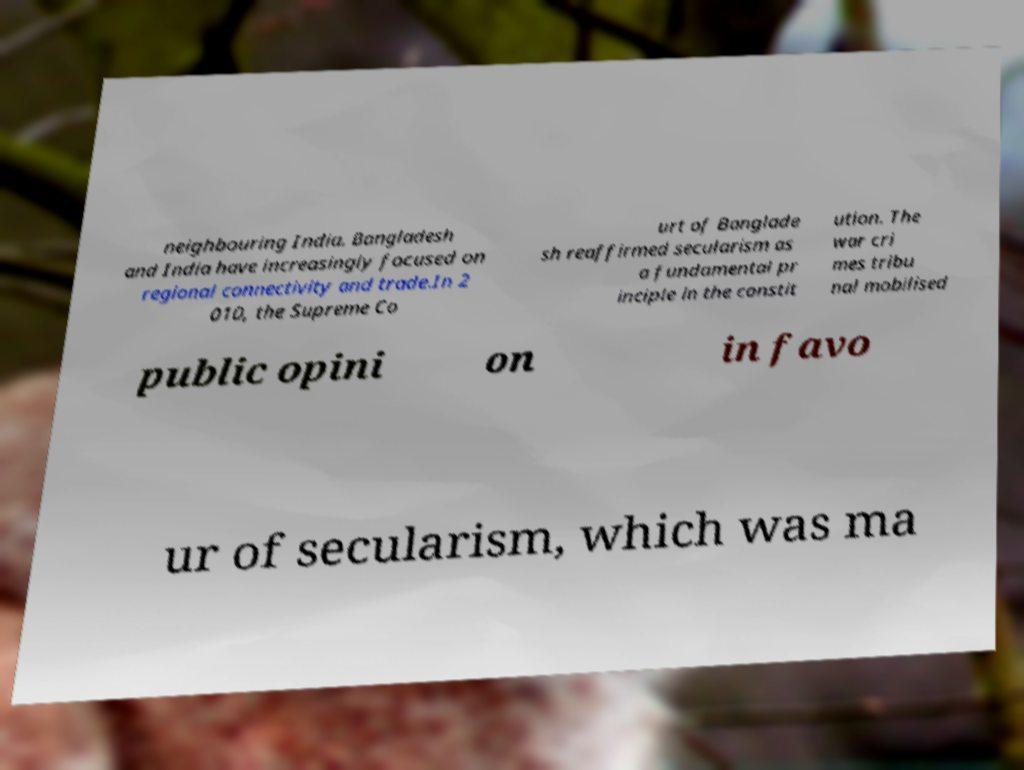Can you accurately transcribe the text from the provided image for me? neighbouring India. Bangladesh and India have increasingly focused on regional connectivity and trade.In 2 010, the Supreme Co urt of Banglade sh reaffirmed secularism as a fundamental pr inciple in the constit ution. The war cri mes tribu nal mobilised public opini on in favo ur of secularism, which was ma 